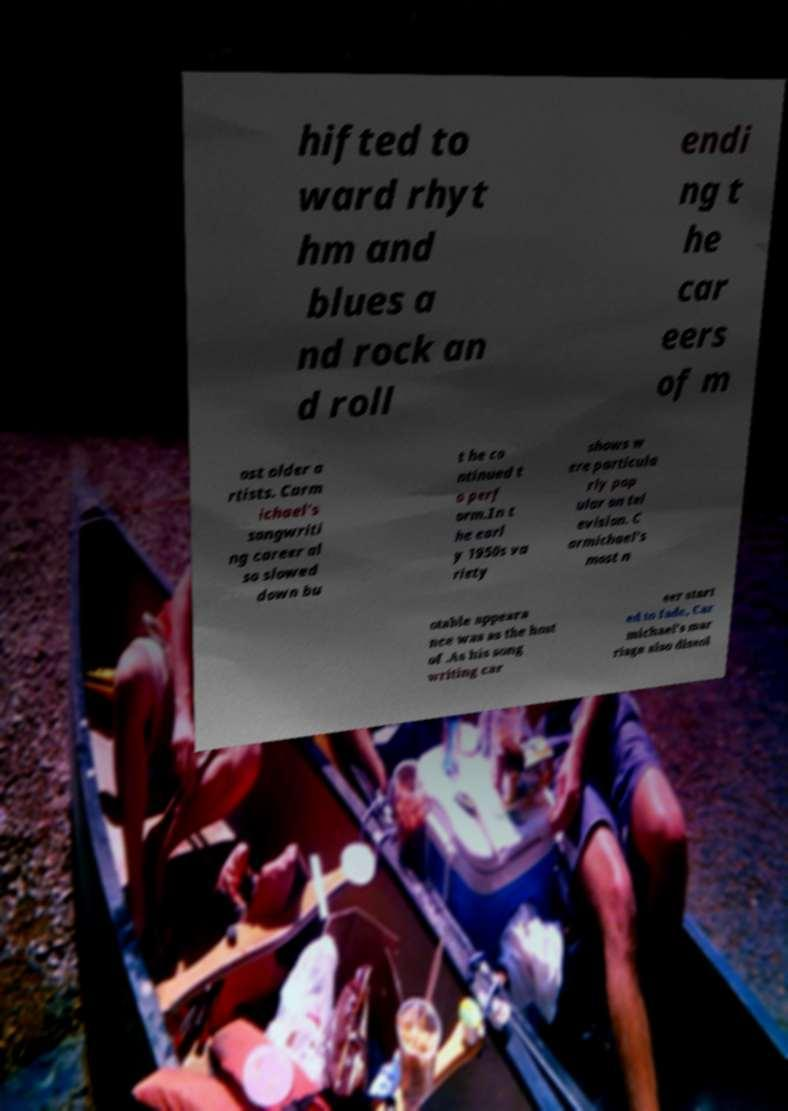I need the written content from this picture converted into text. Can you do that? hifted to ward rhyt hm and blues a nd rock an d roll endi ng t he car eers of m ost older a rtists. Carm ichael's songwriti ng career al so slowed down bu t he co ntinued t o perf orm.In t he earl y 1950s va riety shows w ere particula rly pop ular on tel evision. C armichael's most n otable appeara nce was as the host of .As his song writing car eer start ed to fade, Car michael's mar riage also dissol 